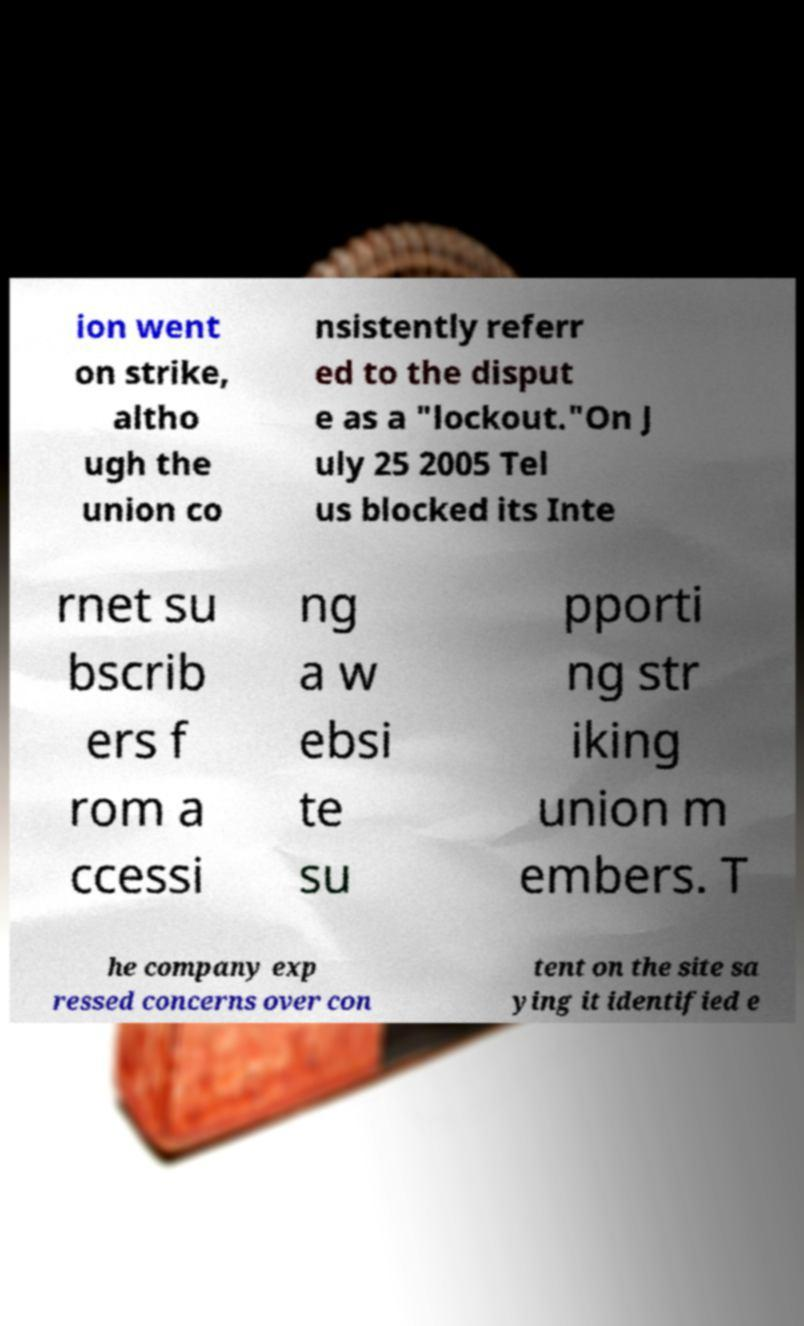Could you extract and type out the text from this image? ion went on strike, altho ugh the union co nsistently referr ed to the disput e as a "lockout."On J uly 25 2005 Tel us blocked its Inte rnet su bscrib ers f rom a ccessi ng a w ebsi te su pporti ng str iking union m embers. T he company exp ressed concerns over con tent on the site sa ying it identified e 